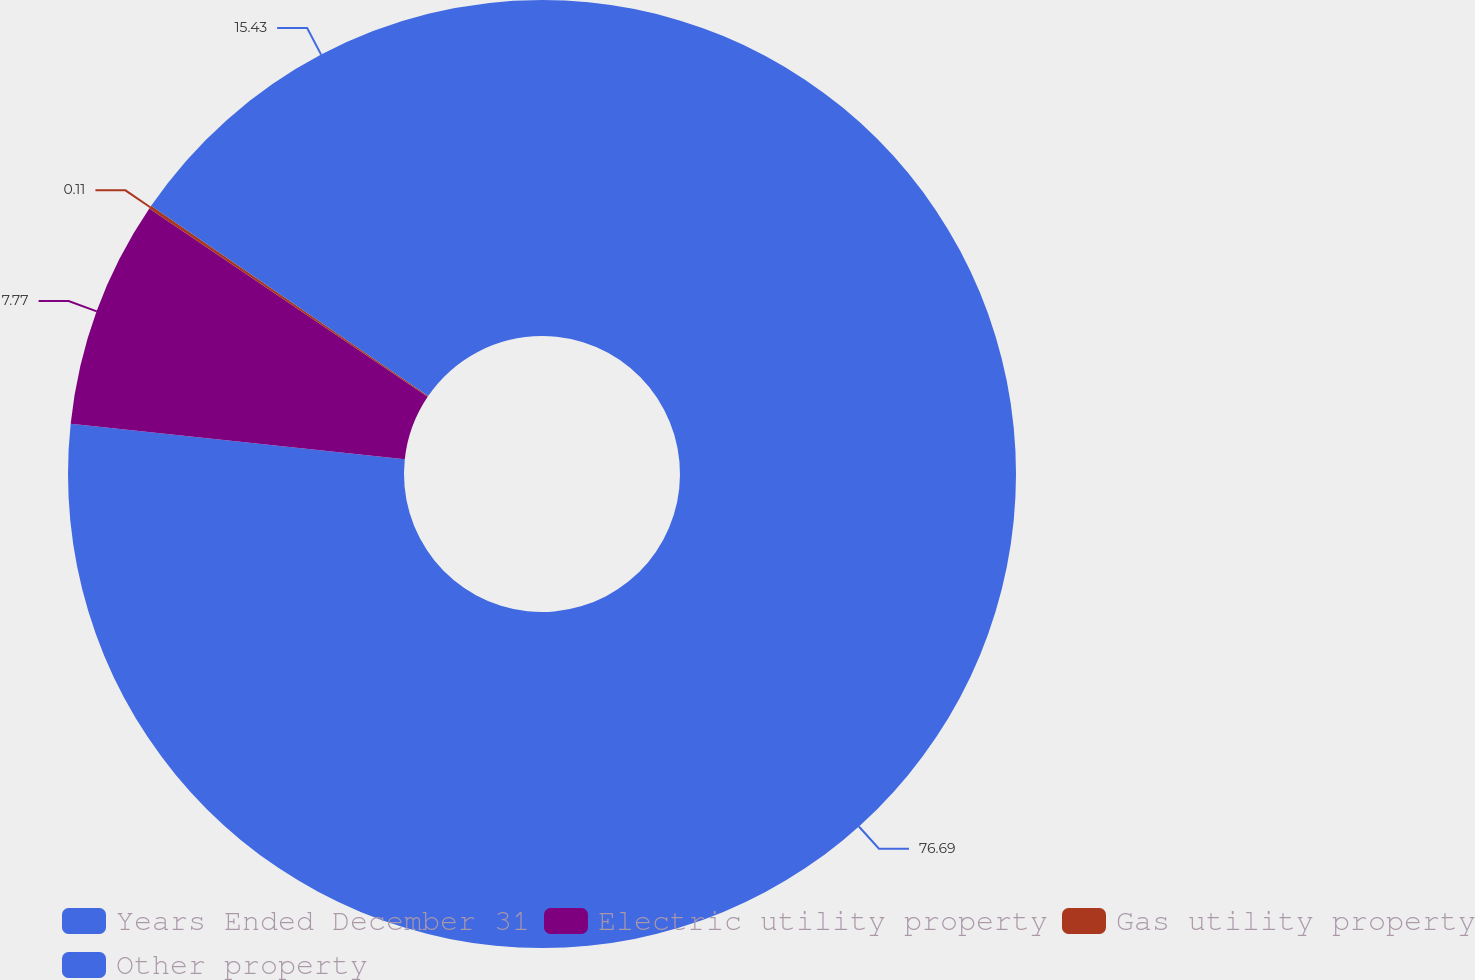Convert chart. <chart><loc_0><loc_0><loc_500><loc_500><pie_chart><fcel>Years Ended December 31<fcel>Electric utility property<fcel>Gas utility property<fcel>Other property<nl><fcel>76.69%<fcel>7.77%<fcel>0.11%<fcel>15.43%<nl></chart> 